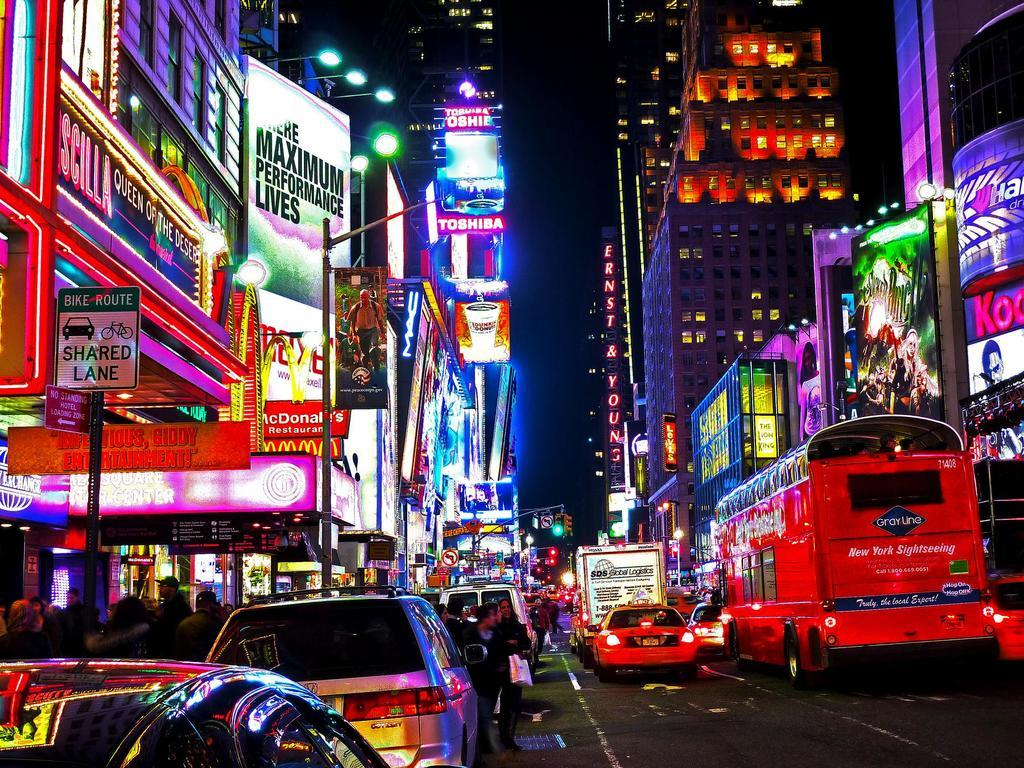<image>
Create a compact narrative representing the image presented. Toshiba is one of the big sponsors on the high rise tv screens. 